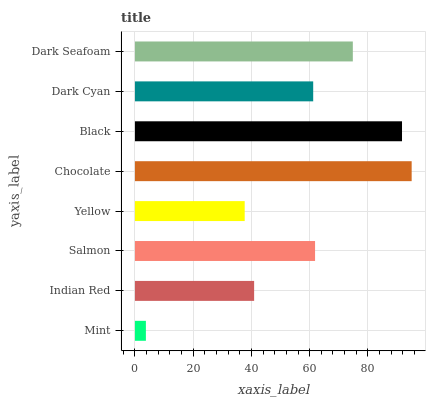Is Mint the minimum?
Answer yes or no. Yes. Is Chocolate the maximum?
Answer yes or no. Yes. Is Indian Red the minimum?
Answer yes or no. No. Is Indian Red the maximum?
Answer yes or no. No. Is Indian Red greater than Mint?
Answer yes or no. Yes. Is Mint less than Indian Red?
Answer yes or no. Yes. Is Mint greater than Indian Red?
Answer yes or no. No. Is Indian Red less than Mint?
Answer yes or no. No. Is Salmon the high median?
Answer yes or no. Yes. Is Dark Cyan the low median?
Answer yes or no. Yes. Is Chocolate the high median?
Answer yes or no. No. Is Salmon the low median?
Answer yes or no. No. 